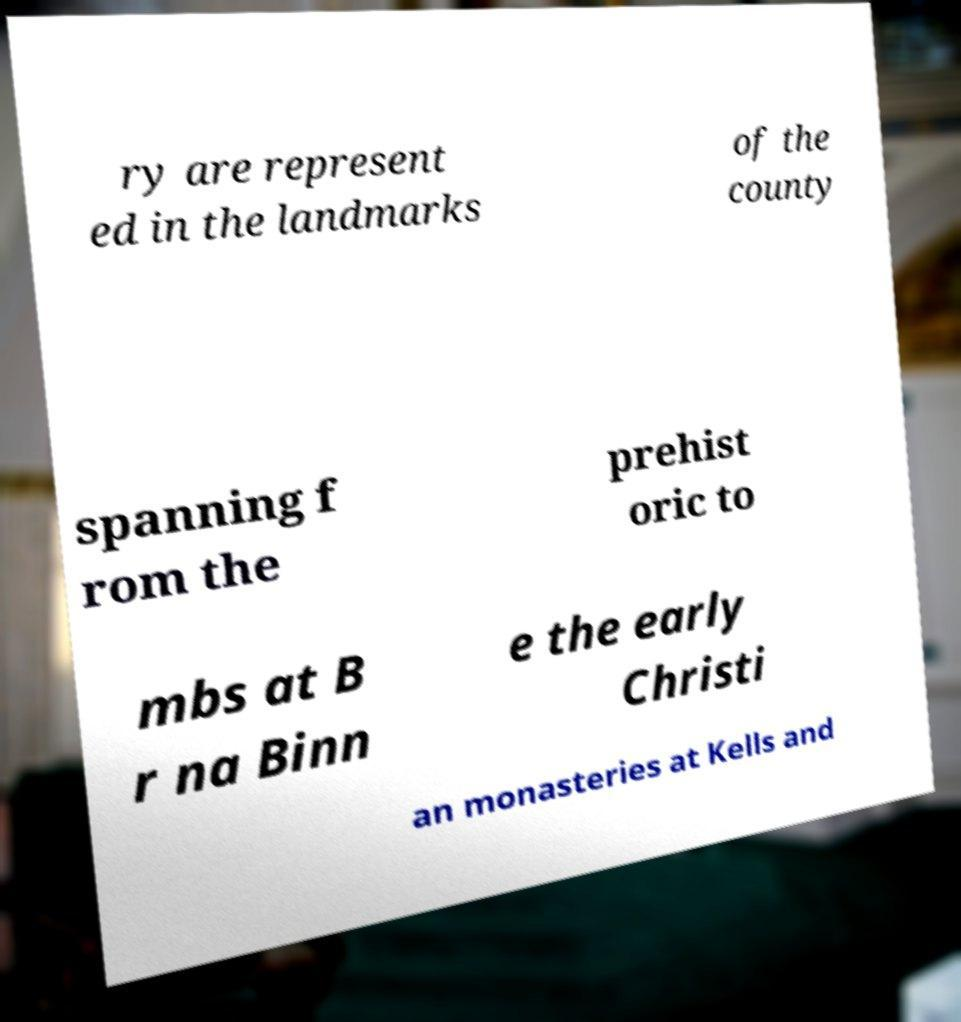Can you accurately transcribe the text from the provided image for me? ry are represent ed in the landmarks of the county spanning f rom the prehist oric to mbs at B r na Binn e the early Christi an monasteries at Kells and 